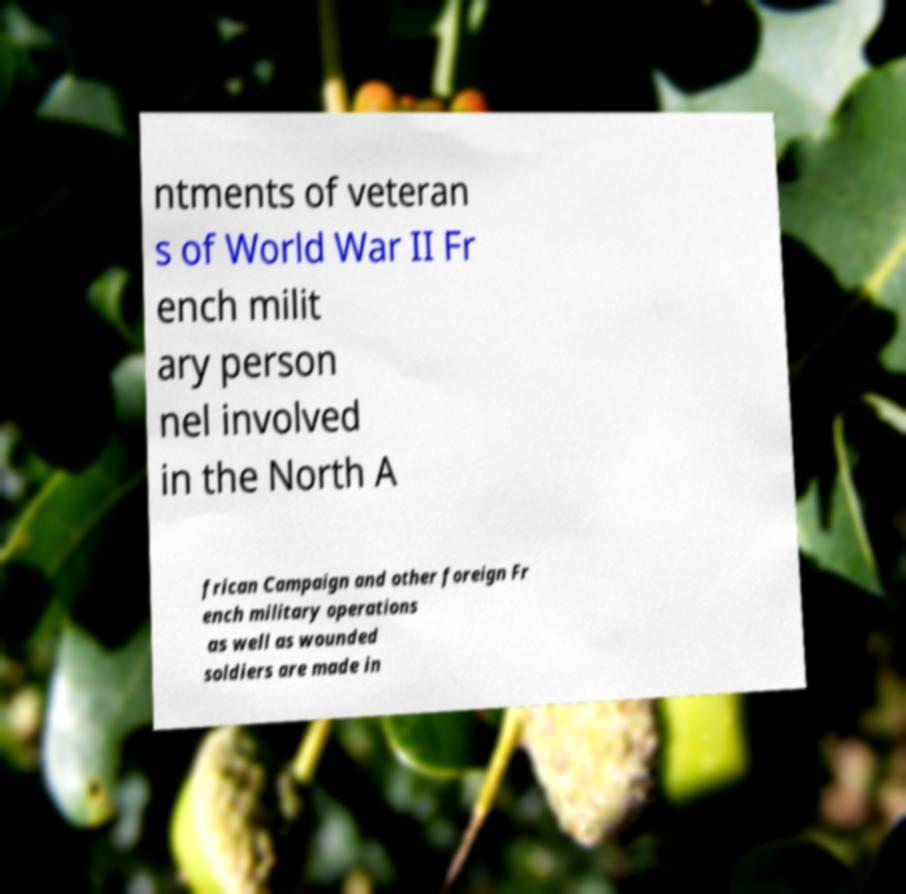I need the written content from this picture converted into text. Can you do that? ntments of veteran s of World War II Fr ench milit ary person nel involved in the North A frican Campaign and other foreign Fr ench military operations as well as wounded soldiers are made in 